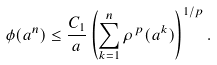<formula> <loc_0><loc_0><loc_500><loc_500>\phi ( a ^ { n } ) \leq \frac { C _ { 1 } } { a } \left ( \sum _ { k = 1 } ^ { n } \rho ^ { \, p } ( a ^ { k } ) \right ) ^ { 1 / p } .</formula> 